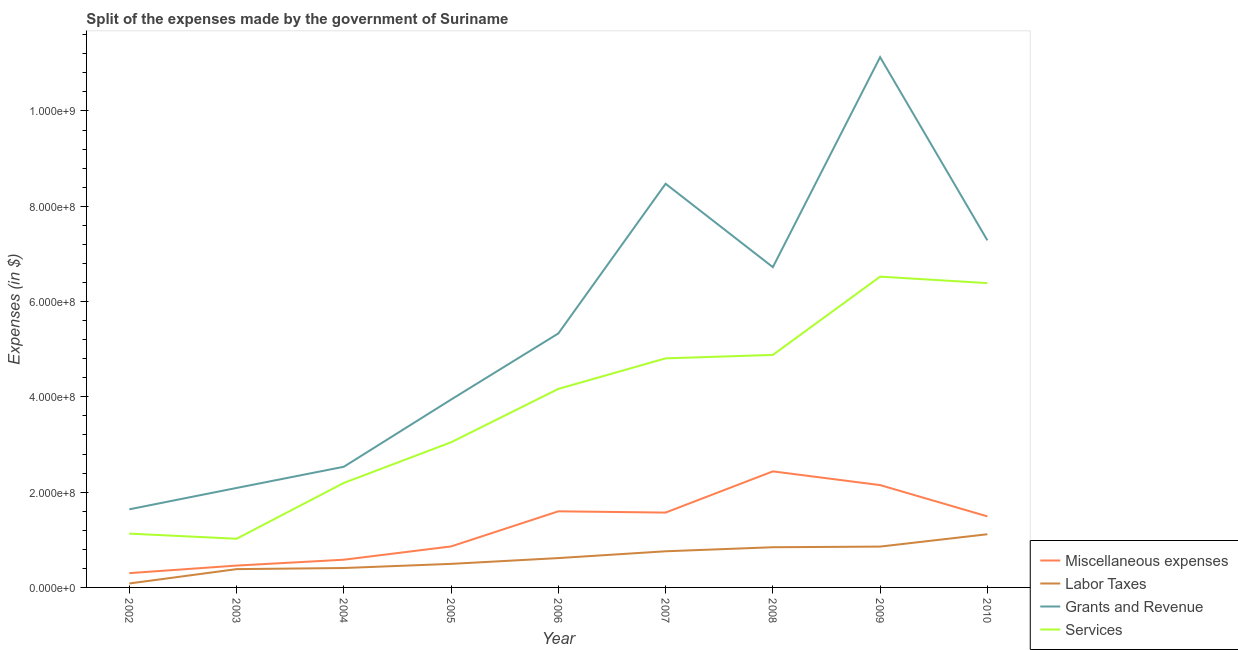How many different coloured lines are there?
Your response must be concise. 4. Is the number of lines equal to the number of legend labels?
Offer a terse response. Yes. What is the amount spent on services in 2008?
Offer a terse response. 4.88e+08. Across all years, what is the maximum amount spent on grants and revenue?
Your answer should be very brief. 1.11e+09. Across all years, what is the minimum amount spent on labor taxes?
Make the answer very short. 8.28e+06. What is the total amount spent on miscellaneous expenses in the graph?
Keep it short and to the point. 1.14e+09. What is the difference between the amount spent on grants and revenue in 2006 and that in 2007?
Make the answer very short. -3.14e+08. What is the difference between the amount spent on services in 2004 and the amount spent on miscellaneous expenses in 2008?
Your response must be concise. -2.42e+07. What is the average amount spent on grants and revenue per year?
Provide a short and direct response. 5.46e+08. In the year 2006, what is the difference between the amount spent on services and amount spent on miscellaneous expenses?
Offer a terse response. 2.57e+08. What is the ratio of the amount spent on labor taxes in 2004 to that in 2008?
Keep it short and to the point. 0.48. Is the amount spent on grants and revenue in 2004 less than that in 2005?
Keep it short and to the point. Yes. What is the difference between the highest and the second highest amount spent on miscellaneous expenses?
Give a very brief answer. 2.88e+07. What is the difference between the highest and the lowest amount spent on miscellaneous expenses?
Your answer should be very brief. 2.14e+08. In how many years, is the amount spent on miscellaneous expenses greater than the average amount spent on miscellaneous expenses taken over all years?
Offer a terse response. 5. Is it the case that in every year, the sum of the amount spent on miscellaneous expenses and amount spent on labor taxes is greater than the amount spent on grants and revenue?
Offer a very short reply. No. Is the amount spent on grants and revenue strictly greater than the amount spent on labor taxes over the years?
Offer a very short reply. Yes. Is the amount spent on services strictly less than the amount spent on labor taxes over the years?
Your response must be concise. No. How many lines are there?
Keep it short and to the point. 4. Does the graph contain grids?
Make the answer very short. No. Where does the legend appear in the graph?
Ensure brevity in your answer.  Bottom right. How many legend labels are there?
Offer a very short reply. 4. What is the title of the graph?
Your response must be concise. Split of the expenses made by the government of Suriname. Does "Tertiary schools" appear as one of the legend labels in the graph?
Your answer should be compact. No. What is the label or title of the X-axis?
Provide a succinct answer. Year. What is the label or title of the Y-axis?
Provide a succinct answer. Expenses (in $). What is the Expenses (in $) in Miscellaneous expenses in 2002?
Provide a succinct answer. 3.00e+07. What is the Expenses (in $) in Labor Taxes in 2002?
Make the answer very short. 8.28e+06. What is the Expenses (in $) in Grants and Revenue in 2002?
Keep it short and to the point. 1.64e+08. What is the Expenses (in $) of Services in 2002?
Ensure brevity in your answer.  1.13e+08. What is the Expenses (in $) in Miscellaneous expenses in 2003?
Your response must be concise. 4.59e+07. What is the Expenses (in $) in Labor Taxes in 2003?
Your response must be concise. 3.84e+07. What is the Expenses (in $) in Grants and Revenue in 2003?
Keep it short and to the point. 2.09e+08. What is the Expenses (in $) of Services in 2003?
Provide a short and direct response. 1.02e+08. What is the Expenses (in $) of Miscellaneous expenses in 2004?
Give a very brief answer. 5.82e+07. What is the Expenses (in $) in Labor Taxes in 2004?
Offer a very short reply. 4.07e+07. What is the Expenses (in $) in Grants and Revenue in 2004?
Your response must be concise. 2.53e+08. What is the Expenses (in $) in Services in 2004?
Your answer should be compact. 2.19e+08. What is the Expenses (in $) in Miscellaneous expenses in 2005?
Offer a very short reply. 8.60e+07. What is the Expenses (in $) in Labor Taxes in 2005?
Ensure brevity in your answer.  4.94e+07. What is the Expenses (in $) of Grants and Revenue in 2005?
Your response must be concise. 3.94e+08. What is the Expenses (in $) of Services in 2005?
Ensure brevity in your answer.  3.05e+08. What is the Expenses (in $) of Miscellaneous expenses in 2006?
Offer a terse response. 1.60e+08. What is the Expenses (in $) of Labor Taxes in 2006?
Your response must be concise. 6.16e+07. What is the Expenses (in $) in Grants and Revenue in 2006?
Offer a terse response. 5.33e+08. What is the Expenses (in $) of Services in 2006?
Your answer should be very brief. 4.17e+08. What is the Expenses (in $) in Miscellaneous expenses in 2007?
Your answer should be compact. 1.57e+08. What is the Expenses (in $) in Labor Taxes in 2007?
Give a very brief answer. 7.59e+07. What is the Expenses (in $) in Grants and Revenue in 2007?
Offer a very short reply. 8.47e+08. What is the Expenses (in $) of Services in 2007?
Your answer should be compact. 4.81e+08. What is the Expenses (in $) of Miscellaneous expenses in 2008?
Offer a very short reply. 2.44e+08. What is the Expenses (in $) in Labor Taxes in 2008?
Your response must be concise. 8.44e+07. What is the Expenses (in $) of Grants and Revenue in 2008?
Provide a short and direct response. 6.72e+08. What is the Expenses (in $) of Services in 2008?
Your answer should be very brief. 4.88e+08. What is the Expenses (in $) of Miscellaneous expenses in 2009?
Offer a very short reply. 2.15e+08. What is the Expenses (in $) in Labor Taxes in 2009?
Your answer should be very brief. 8.57e+07. What is the Expenses (in $) in Grants and Revenue in 2009?
Provide a succinct answer. 1.11e+09. What is the Expenses (in $) of Services in 2009?
Provide a short and direct response. 6.52e+08. What is the Expenses (in $) of Miscellaneous expenses in 2010?
Ensure brevity in your answer.  1.49e+08. What is the Expenses (in $) of Labor Taxes in 2010?
Ensure brevity in your answer.  1.12e+08. What is the Expenses (in $) in Grants and Revenue in 2010?
Your answer should be very brief. 7.28e+08. What is the Expenses (in $) in Services in 2010?
Ensure brevity in your answer.  6.39e+08. Across all years, what is the maximum Expenses (in $) of Miscellaneous expenses?
Your response must be concise. 2.44e+08. Across all years, what is the maximum Expenses (in $) in Labor Taxes?
Make the answer very short. 1.12e+08. Across all years, what is the maximum Expenses (in $) in Grants and Revenue?
Ensure brevity in your answer.  1.11e+09. Across all years, what is the maximum Expenses (in $) of Services?
Give a very brief answer. 6.52e+08. Across all years, what is the minimum Expenses (in $) of Miscellaneous expenses?
Make the answer very short. 3.00e+07. Across all years, what is the minimum Expenses (in $) in Labor Taxes?
Give a very brief answer. 8.28e+06. Across all years, what is the minimum Expenses (in $) of Grants and Revenue?
Ensure brevity in your answer.  1.64e+08. Across all years, what is the minimum Expenses (in $) in Services?
Provide a short and direct response. 1.02e+08. What is the total Expenses (in $) in Miscellaneous expenses in the graph?
Give a very brief answer. 1.14e+09. What is the total Expenses (in $) in Labor Taxes in the graph?
Provide a succinct answer. 5.56e+08. What is the total Expenses (in $) of Grants and Revenue in the graph?
Your answer should be very brief. 4.91e+09. What is the total Expenses (in $) in Services in the graph?
Provide a succinct answer. 3.42e+09. What is the difference between the Expenses (in $) in Miscellaneous expenses in 2002 and that in 2003?
Make the answer very short. -1.59e+07. What is the difference between the Expenses (in $) of Labor Taxes in 2002 and that in 2003?
Keep it short and to the point. -3.01e+07. What is the difference between the Expenses (in $) in Grants and Revenue in 2002 and that in 2003?
Your response must be concise. -4.48e+07. What is the difference between the Expenses (in $) of Services in 2002 and that in 2003?
Provide a succinct answer. 1.08e+07. What is the difference between the Expenses (in $) in Miscellaneous expenses in 2002 and that in 2004?
Your answer should be very brief. -2.82e+07. What is the difference between the Expenses (in $) in Labor Taxes in 2002 and that in 2004?
Provide a succinct answer. -3.24e+07. What is the difference between the Expenses (in $) of Grants and Revenue in 2002 and that in 2004?
Your answer should be compact. -8.93e+07. What is the difference between the Expenses (in $) in Services in 2002 and that in 2004?
Keep it short and to the point. -1.06e+08. What is the difference between the Expenses (in $) in Miscellaneous expenses in 2002 and that in 2005?
Ensure brevity in your answer.  -5.60e+07. What is the difference between the Expenses (in $) of Labor Taxes in 2002 and that in 2005?
Ensure brevity in your answer.  -4.11e+07. What is the difference between the Expenses (in $) of Grants and Revenue in 2002 and that in 2005?
Your answer should be compact. -2.30e+08. What is the difference between the Expenses (in $) in Services in 2002 and that in 2005?
Offer a very short reply. -1.92e+08. What is the difference between the Expenses (in $) of Miscellaneous expenses in 2002 and that in 2006?
Provide a short and direct response. -1.30e+08. What is the difference between the Expenses (in $) of Labor Taxes in 2002 and that in 2006?
Your answer should be compact. -5.33e+07. What is the difference between the Expenses (in $) of Grants and Revenue in 2002 and that in 2006?
Keep it short and to the point. -3.69e+08. What is the difference between the Expenses (in $) of Services in 2002 and that in 2006?
Make the answer very short. -3.04e+08. What is the difference between the Expenses (in $) in Miscellaneous expenses in 2002 and that in 2007?
Ensure brevity in your answer.  -1.27e+08. What is the difference between the Expenses (in $) in Labor Taxes in 2002 and that in 2007?
Make the answer very short. -6.76e+07. What is the difference between the Expenses (in $) in Grants and Revenue in 2002 and that in 2007?
Keep it short and to the point. -6.83e+08. What is the difference between the Expenses (in $) in Services in 2002 and that in 2007?
Your answer should be very brief. -3.68e+08. What is the difference between the Expenses (in $) of Miscellaneous expenses in 2002 and that in 2008?
Provide a short and direct response. -2.14e+08. What is the difference between the Expenses (in $) in Labor Taxes in 2002 and that in 2008?
Your response must be concise. -7.61e+07. What is the difference between the Expenses (in $) of Grants and Revenue in 2002 and that in 2008?
Make the answer very short. -5.08e+08. What is the difference between the Expenses (in $) in Services in 2002 and that in 2008?
Make the answer very short. -3.75e+08. What is the difference between the Expenses (in $) of Miscellaneous expenses in 2002 and that in 2009?
Your answer should be very brief. -1.85e+08. What is the difference between the Expenses (in $) in Labor Taxes in 2002 and that in 2009?
Ensure brevity in your answer.  -7.74e+07. What is the difference between the Expenses (in $) in Grants and Revenue in 2002 and that in 2009?
Provide a succinct answer. -9.49e+08. What is the difference between the Expenses (in $) of Services in 2002 and that in 2009?
Give a very brief answer. -5.39e+08. What is the difference between the Expenses (in $) in Miscellaneous expenses in 2002 and that in 2010?
Ensure brevity in your answer.  -1.19e+08. What is the difference between the Expenses (in $) in Labor Taxes in 2002 and that in 2010?
Give a very brief answer. -1.03e+08. What is the difference between the Expenses (in $) of Grants and Revenue in 2002 and that in 2010?
Offer a very short reply. -5.65e+08. What is the difference between the Expenses (in $) in Services in 2002 and that in 2010?
Provide a short and direct response. -5.26e+08. What is the difference between the Expenses (in $) of Miscellaneous expenses in 2003 and that in 2004?
Provide a short and direct response. -1.23e+07. What is the difference between the Expenses (in $) in Labor Taxes in 2003 and that in 2004?
Provide a succinct answer. -2.33e+06. What is the difference between the Expenses (in $) of Grants and Revenue in 2003 and that in 2004?
Ensure brevity in your answer.  -4.45e+07. What is the difference between the Expenses (in $) in Services in 2003 and that in 2004?
Provide a short and direct response. -1.17e+08. What is the difference between the Expenses (in $) of Miscellaneous expenses in 2003 and that in 2005?
Offer a very short reply. -4.02e+07. What is the difference between the Expenses (in $) of Labor Taxes in 2003 and that in 2005?
Give a very brief answer. -1.10e+07. What is the difference between the Expenses (in $) of Grants and Revenue in 2003 and that in 2005?
Offer a very short reply. -1.86e+08. What is the difference between the Expenses (in $) of Services in 2003 and that in 2005?
Make the answer very short. -2.02e+08. What is the difference between the Expenses (in $) in Miscellaneous expenses in 2003 and that in 2006?
Provide a short and direct response. -1.14e+08. What is the difference between the Expenses (in $) in Labor Taxes in 2003 and that in 2006?
Give a very brief answer. -2.32e+07. What is the difference between the Expenses (in $) of Grants and Revenue in 2003 and that in 2006?
Offer a terse response. -3.24e+08. What is the difference between the Expenses (in $) of Services in 2003 and that in 2006?
Your answer should be very brief. -3.15e+08. What is the difference between the Expenses (in $) in Miscellaneous expenses in 2003 and that in 2007?
Ensure brevity in your answer.  -1.11e+08. What is the difference between the Expenses (in $) in Labor Taxes in 2003 and that in 2007?
Keep it short and to the point. -3.75e+07. What is the difference between the Expenses (in $) of Grants and Revenue in 2003 and that in 2007?
Provide a succinct answer. -6.38e+08. What is the difference between the Expenses (in $) in Services in 2003 and that in 2007?
Keep it short and to the point. -3.79e+08. What is the difference between the Expenses (in $) of Miscellaneous expenses in 2003 and that in 2008?
Your answer should be compact. -1.98e+08. What is the difference between the Expenses (in $) of Labor Taxes in 2003 and that in 2008?
Your answer should be very brief. -4.60e+07. What is the difference between the Expenses (in $) in Grants and Revenue in 2003 and that in 2008?
Offer a very short reply. -4.63e+08. What is the difference between the Expenses (in $) of Services in 2003 and that in 2008?
Ensure brevity in your answer.  -3.86e+08. What is the difference between the Expenses (in $) of Miscellaneous expenses in 2003 and that in 2009?
Make the answer very short. -1.69e+08. What is the difference between the Expenses (in $) of Labor Taxes in 2003 and that in 2009?
Ensure brevity in your answer.  -4.73e+07. What is the difference between the Expenses (in $) in Grants and Revenue in 2003 and that in 2009?
Your response must be concise. -9.04e+08. What is the difference between the Expenses (in $) of Services in 2003 and that in 2009?
Your answer should be very brief. -5.50e+08. What is the difference between the Expenses (in $) in Miscellaneous expenses in 2003 and that in 2010?
Keep it short and to the point. -1.03e+08. What is the difference between the Expenses (in $) in Labor Taxes in 2003 and that in 2010?
Offer a very short reply. -7.32e+07. What is the difference between the Expenses (in $) in Grants and Revenue in 2003 and that in 2010?
Give a very brief answer. -5.20e+08. What is the difference between the Expenses (in $) in Services in 2003 and that in 2010?
Give a very brief answer. -5.37e+08. What is the difference between the Expenses (in $) of Miscellaneous expenses in 2004 and that in 2005?
Your response must be concise. -2.79e+07. What is the difference between the Expenses (in $) in Labor Taxes in 2004 and that in 2005?
Give a very brief answer. -8.70e+06. What is the difference between the Expenses (in $) in Grants and Revenue in 2004 and that in 2005?
Make the answer very short. -1.41e+08. What is the difference between the Expenses (in $) in Services in 2004 and that in 2005?
Provide a short and direct response. -8.53e+07. What is the difference between the Expenses (in $) of Miscellaneous expenses in 2004 and that in 2006?
Offer a terse response. -1.02e+08. What is the difference between the Expenses (in $) in Labor Taxes in 2004 and that in 2006?
Keep it short and to the point. -2.09e+07. What is the difference between the Expenses (in $) of Grants and Revenue in 2004 and that in 2006?
Give a very brief answer. -2.80e+08. What is the difference between the Expenses (in $) of Services in 2004 and that in 2006?
Keep it short and to the point. -1.97e+08. What is the difference between the Expenses (in $) of Miscellaneous expenses in 2004 and that in 2007?
Keep it short and to the point. -9.89e+07. What is the difference between the Expenses (in $) of Labor Taxes in 2004 and that in 2007?
Keep it short and to the point. -3.51e+07. What is the difference between the Expenses (in $) of Grants and Revenue in 2004 and that in 2007?
Provide a succinct answer. -5.94e+08. What is the difference between the Expenses (in $) in Services in 2004 and that in 2007?
Provide a short and direct response. -2.61e+08. What is the difference between the Expenses (in $) in Miscellaneous expenses in 2004 and that in 2008?
Offer a very short reply. -1.85e+08. What is the difference between the Expenses (in $) in Labor Taxes in 2004 and that in 2008?
Ensure brevity in your answer.  -4.36e+07. What is the difference between the Expenses (in $) of Grants and Revenue in 2004 and that in 2008?
Offer a very short reply. -4.19e+08. What is the difference between the Expenses (in $) in Services in 2004 and that in 2008?
Offer a terse response. -2.69e+08. What is the difference between the Expenses (in $) of Miscellaneous expenses in 2004 and that in 2009?
Ensure brevity in your answer.  -1.57e+08. What is the difference between the Expenses (in $) of Labor Taxes in 2004 and that in 2009?
Make the answer very short. -4.50e+07. What is the difference between the Expenses (in $) in Grants and Revenue in 2004 and that in 2009?
Ensure brevity in your answer.  -8.60e+08. What is the difference between the Expenses (in $) of Services in 2004 and that in 2009?
Offer a terse response. -4.33e+08. What is the difference between the Expenses (in $) in Miscellaneous expenses in 2004 and that in 2010?
Make the answer very short. -9.10e+07. What is the difference between the Expenses (in $) of Labor Taxes in 2004 and that in 2010?
Your answer should be compact. -7.09e+07. What is the difference between the Expenses (in $) of Grants and Revenue in 2004 and that in 2010?
Your answer should be compact. -4.75e+08. What is the difference between the Expenses (in $) in Services in 2004 and that in 2010?
Your answer should be very brief. -4.19e+08. What is the difference between the Expenses (in $) in Miscellaneous expenses in 2005 and that in 2006?
Make the answer very short. -7.37e+07. What is the difference between the Expenses (in $) of Labor Taxes in 2005 and that in 2006?
Your response must be concise. -1.22e+07. What is the difference between the Expenses (in $) of Grants and Revenue in 2005 and that in 2006?
Your answer should be compact. -1.39e+08. What is the difference between the Expenses (in $) in Services in 2005 and that in 2006?
Ensure brevity in your answer.  -1.12e+08. What is the difference between the Expenses (in $) in Miscellaneous expenses in 2005 and that in 2007?
Ensure brevity in your answer.  -7.11e+07. What is the difference between the Expenses (in $) in Labor Taxes in 2005 and that in 2007?
Give a very brief answer. -2.64e+07. What is the difference between the Expenses (in $) of Grants and Revenue in 2005 and that in 2007?
Ensure brevity in your answer.  -4.53e+08. What is the difference between the Expenses (in $) in Services in 2005 and that in 2007?
Your answer should be very brief. -1.76e+08. What is the difference between the Expenses (in $) of Miscellaneous expenses in 2005 and that in 2008?
Your answer should be compact. -1.58e+08. What is the difference between the Expenses (in $) of Labor Taxes in 2005 and that in 2008?
Offer a terse response. -3.49e+07. What is the difference between the Expenses (in $) in Grants and Revenue in 2005 and that in 2008?
Give a very brief answer. -2.78e+08. What is the difference between the Expenses (in $) in Services in 2005 and that in 2008?
Your response must be concise. -1.83e+08. What is the difference between the Expenses (in $) in Miscellaneous expenses in 2005 and that in 2009?
Your response must be concise. -1.29e+08. What is the difference between the Expenses (in $) in Labor Taxes in 2005 and that in 2009?
Ensure brevity in your answer.  -3.63e+07. What is the difference between the Expenses (in $) in Grants and Revenue in 2005 and that in 2009?
Your response must be concise. -7.19e+08. What is the difference between the Expenses (in $) of Services in 2005 and that in 2009?
Provide a succinct answer. -3.48e+08. What is the difference between the Expenses (in $) in Miscellaneous expenses in 2005 and that in 2010?
Your answer should be very brief. -6.31e+07. What is the difference between the Expenses (in $) in Labor Taxes in 2005 and that in 2010?
Offer a terse response. -6.22e+07. What is the difference between the Expenses (in $) in Grants and Revenue in 2005 and that in 2010?
Offer a very short reply. -3.34e+08. What is the difference between the Expenses (in $) of Services in 2005 and that in 2010?
Make the answer very short. -3.34e+08. What is the difference between the Expenses (in $) of Miscellaneous expenses in 2006 and that in 2007?
Provide a succinct answer. 2.63e+06. What is the difference between the Expenses (in $) in Labor Taxes in 2006 and that in 2007?
Offer a terse response. -1.43e+07. What is the difference between the Expenses (in $) of Grants and Revenue in 2006 and that in 2007?
Your response must be concise. -3.14e+08. What is the difference between the Expenses (in $) in Services in 2006 and that in 2007?
Your answer should be compact. -6.41e+07. What is the difference between the Expenses (in $) of Miscellaneous expenses in 2006 and that in 2008?
Provide a succinct answer. -8.39e+07. What is the difference between the Expenses (in $) in Labor Taxes in 2006 and that in 2008?
Provide a succinct answer. -2.28e+07. What is the difference between the Expenses (in $) of Grants and Revenue in 2006 and that in 2008?
Your answer should be compact. -1.39e+08. What is the difference between the Expenses (in $) in Services in 2006 and that in 2008?
Provide a succinct answer. -7.13e+07. What is the difference between the Expenses (in $) of Miscellaneous expenses in 2006 and that in 2009?
Keep it short and to the point. -5.50e+07. What is the difference between the Expenses (in $) in Labor Taxes in 2006 and that in 2009?
Your answer should be very brief. -2.41e+07. What is the difference between the Expenses (in $) of Grants and Revenue in 2006 and that in 2009?
Ensure brevity in your answer.  -5.80e+08. What is the difference between the Expenses (in $) in Services in 2006 and that in 2009?
Provide a succinct answer. -2.36e+08. What is the difference between the Expenses (in $) in Miscellaneous expenses in 2006 and that in 2010?
Your answer should be very brief. 1.06e+07. What is the difference between the Expenses (in $) of Labor Taxes in 2006 and that in 2010?
Your answer should be compact. -5.00e+07. What is the difference between the Expenses (in $) in Grants and Revenue in 2006 and that in 2010?
Provide a short and direct response. -1.95e+08. What is the difference between the Expenses (in $) of Services in 2006 and that in 2010?
Your answer should be very brief. -2.22e+08. What is the difference between the Expenses (in $) of Miscellaneous expenses in 2007 and that in 2008?
Your response must be concise. -8.65e+07. What is the difference between the Expenses (in $) in Labor Taxes in 2007 and that in 2008?
Provide a short and direct response. -8.51e+06. What is the difference between the Expenses (in $) of Grants and Revenue in 2007 and that in 2008?
Keep it short and to the point. 1.75e+08. What is the difference between the Expenses (in $) in Services in 2007 and that in 2008?
Keep it short and to the point. -7.24e+06. What is the difference between the Expenses (in $) in Miscellaneous expenses in 2007 and that in 2009?
Keep it short and to the point. -5.77e+07. What is the difference between the Expenses (in $) of Labor Taxes in 2007 and that in 2009?
Provide a succinct answer. -9.85e+06. What is the difference between the Expenses (in $) in Grants and Revenue in 2007 and that in 2009?
Offer a terse response. -2.66e+08. What is the difference between the Expenses (in $) in Services in 2007 and that in 2009?
Make the answer very short. -1.71e+08. What is the difference between the Expenses (in $) in Miscellaneous expenses in 2007 and that in 2010?
Keep it short and to the point. 7.95e+06. What is the difference between the Expenses (in $) in Labor Taxes in 2007 and that in 2010?
Ensure brevity in your answer.  -3.58e+07. What is the difference between the Expenses (in $) in Grants and Revenue in 2007 and that in 2010?
Provide a succinct answer. 1.19e+08. What is the difference between the Expenses (in $) of Services in 2007 and that in 2010?
Ensure brevity in your answer.  -1.58e+08. What is the difference between the Expenses (in $) of Miscellaneous expenses in 2008 and that in 2009?
Provide a succinct answer. 2.88e+07. What is the difference between the Expenses (in $) in Labor Taxes in 2008 and that in 2009?
Ensure brevity in your answer.  -1.34e+06. What is the difference between the Expenses (in $) of Grants and Revenue in 2008 and that in 2009?
Your response must be concise. -4.41e+08. What is the difference between the Expenses (in $) of Services in 2008 and that in 2009?
Your response must be concise. -1.64e+08. What is the difference between the Expenses (in $) of Miscellaneous expenses in 2008 and that in 2010?
Offer a terse response. 9.44e+07. What is the difference between the Expenses (in $) in Labor Taxes in 2008 and that in 2010?
Offer a terse response. -2.73e+07. What is the difference between the Expenses (in $) of Grants and Revenue in 2008 and that in 2010?
Your response must be concise. -5.62e+07. What is the difference between the Expenses (in $) of Services in 2008 and that in 2010?
Ensure brevity in your answer.  -1.51e+08. What is the difference between the Expenses (in $) in Miscellaneous expenses in 2009 and that in 2010?
Offer a very short reply. 6.56e+07. What is the difference between the Expenses (in $) in Labor Taxes in 2009 and that in 2010?
Your answer should be compact. -2.59e+07. What is the difference between the Expenses (in $) in Grants and Revenue in 2009 and that in 2010?
Ensure brevity in your answer.  3.84e+08. What is the difference between the Expenses (in $) of Services in 2009 and that in 2010?
Your answer should be very brief. 1.36e+07. What is the difference between the Expenses (in $) of Miscellaneous expenses in 2002 and the Expenses (in $) of Labor Taxes in 2003?
Ensure brevity in your answer.  -8.40e+06. What is the difference between the Expenses (in $) in Miscellaneous expenses in 2002 and the Expenses (in $) in Grants and Revenue in 2003?
Give a very brief answer. -1.79e+08. What is the difference between the Expenses (in $) of Miscellaneous expenses in 2002 and the Expenses (in $) of Services in 2003?
Your answer should be very brief. -7.22e+07. What is the difference between the Expenses (in $) in Labor Taxes in 2002 and the Expenses (in $) in Grants and Revenue in 2003?
Offer a very short reply. -2.00e+08. What is the difference between the Expenses (in $) in Labor Taxes in 2002 and the Expenses (in $) in Services in 2003?
Keep it short and to the point. -9.39e+07. What is the difference between the Expenses (in $) of Grants and Revenue in 2002 and the Expenses (in $) of Services in 2003?
Give a very brief answer. 6.18e+07. What is the difference between the Expenses (in $) of Miscellaneous expenses in 2002 and the Expenses (in $) of Labor Taxes in 2004?
Your answer should be very brief. -1.07e+07. What is the difference between the Expenses (in $) in Miscellaneous expenses in 2002 and the Expenses (in $) in Grants and Revenue in 2004?
Offer a terse response. -2.23e+08. What is the difference between the Expenses (in $) in Miscellaneous expenses in 2002 and the Expenses (in $) in Services in 2004?
Your response must be concise. -1.89e+08. What is the difference between the Expenses (in $) in Labor Taxes in 2002 and the Expenses (in $) in Grants and Revenue in 2004?
Give a very brief answer. -2.45e+08. What is the difference between the Expenses (in $) in Labor Taxes in 2002 and the Expenses (in $) in Services in 2004?
Make the answer very short. -2.11e+08. What is the difference between the Expenses (in $) of Grants and Revenue in 2002 and the Expenses (in $) of Services in 2004?
Provide a succinct answer. -5.54e+07. What is the difference between the Expenses (in $) of Miscellaneous expenses in 2002 and the Expenses (in $) of Labor Taxes in 2005?
Provide a short and direct response. -1.94e+07. What is the difference between the Expenses (in $) in Miscellaneous expenses in 2002 and the Expenses (in $) in Grants and Revenue in 2005?
Your answer should be very brief. -3.64e+08. What is the difference between the Expenses (in $) of Miscellaneous expenses in 2002 and the Expenses (in $) of Services in 2005?
Make the answer very short. -2.75e+08. What is the difference between the Expenses (in $) of Labor Taxes in 2002 and the Expenses (in $) of Grants and Revenue in 2005?
Make the answer very short. -3.86e+08. What is the difference between the Expenses (in $) of Labor Taxes in 2002 and the Expenses (in $) of Services in 2005?
Provide a succinct answer. -2.96e+08. What is the difference between the Expenses (in $) of Grants and Revenue in 2002 and the Expenses (in $) of Services in 2005?
Ensure brevity in your answer.  -1.41e+08. What is the difference between the Expenses (in $) of Miscellaneous expenses in 2002 and the Expenses (in $) of Labor Taxes in 2006?
Your answer should be very brief. -3.16e+07. What is the difference between the Expenses (in $) in Miscellaneous expenses in 2002 and the Expenses (in $) in Grants and Revenue in 2006?
Your answer should be very brief. -5.03e+08. What is the difference between the Expenses (in $) in Miscellaneous expenses in 2002 and the Expenses (in $) in Services in 2006?
Give a very brief answer. -3.87e+08. What is the difference between the Expenses (in $) of Labor Taxes in 2002 and the Expenses (in $) of Grants and Revenue in 2006?
Offer a terse response. -5.25e+08. What is the difference between the Expenses (in $) in Labor Taxes in 2002 and the Expenses (in $) in Services in 2006?
Make the answer very short. -4.08e+08. What is the difference between the Expenses (in $) in Grants and Revenue in 2002 and the Expenses (in $) in Services in 2006?
Keep it short and to the point. -2.53e+08. What is the difference between the Expenses (in $) in Miscellaneous expenses in 2002 and the Expenses (in $) in Labor Taxes in 2007?
Offer a very short reply. -4.59e+07. What is the difference between the Expenses (in $) in Miscellaneous expenses in 2002 and the Expenses (in $) in Grants and Revenue in 2007?
Keep it short and to the point. -8.17e+08. What is the difference between the Expenses (in $) in Miscellaneous expenses in 2002 and the Expenses (in $) in Services in 2007?
Offer a very short reply. -4.51e+08. What is the difference between the Expenses (in $) in Labor Taxes in 2002 and the Expenses (in $) in Grants and Revenue in 2007?
Your answer should be very brief. -8.39e+08. What is the difference between the Expenses (in $) of Labor Taxes in 2002 and the Expenses (in $) of Services in 2007?
Ensure brevity in your answer.  -4.72e+08. What is the difference between the Expenses (in $) in Grants and Revenue in 2002 and the Expenses (in $) in Services in 2007?
Offer a terse response. -3.17e+08. What is the difference between the Expenses (in $) in Miscellaneous expenses in 2002 and the Expenses (in $) in Labor Taxes in 2008?
Your answer should be compact. -5.44e+07. What is the difference between the Expenses (in $) in Miscellaneous expenses in 2002 and the Expenses (in $) in Grants and Revenue in 2008?
Offer a terse response. -6.42e+08. What is the difference between the Expenses (in $) in Miscellaneous expenses in 2002 and the Expenses (in $) in Services in 2008?
Provide a succinct answer. -4.58e+08. What is the difference between the Expenses (in $) in Labor Taxes in 2002 and the Expenses (in $) in Grants and Revenue in 2008?
Your answer should be very brief. -6.64e+08. What is the difference between the Expenses (in $) in Labor Taxes in 2002 and the Expenses (in $) in Services in 2008?
Provide a succinct answer. -4.80e+08. What is the difference between the Expenses (in $) of Grants and Revenue in 2002 and the Expenses (in $) of Services in 2008?
Keep it short and to the point. -3.24e+08. What is the difference between the Expenses (in $) of Miscellaneous expenses in 2002 and the Expenses (in $) of Labor Taxes in 2009?
Make the answer very short. -5.57e+07. What is the difference between the Expenses (in $) of Miscellaneous expenses in 2002 and the Expenses (in $) of Grants and Revenue in 2009?
Your answer should be very brief. -1.08e+09. What is the difference between the Expenses (in $) of Miscellaneous expenses in 2002 and the Expenses (in $) of Services in 2009?
Give a very brief answer. -6.22e+08. What is the difference between the Expenses (in $) in Labor Taxes in 2002 and the Expenses (in $) in Grants and Revenue in 2009?
Keep it short and to the point. -1.10e+09. What is the difference between the Expenses (in $) in Labor Taxes in 2002 and the Expenses (in $) in Services in 2009?
Your response must be concise. -6.44e+08. What is the difference between the Expenses (in $) of Grants and Revenue in 2002 and the Expenses (in $) of Services in 2009?
Offer a very short reply. -4.88e+08. What is the difference between the Expenses (in $) in Miscellaneous expenses in 2002 and the Expenses (in $) in Labor Taxes in 2010?
Your answer should be compact. -8.16e+07. What is the difference between the Expenses (in $) of Miscellaneous expenses in 2002 and the Expenses (in $) of Grants and Revenue in 2010?
Give a very brief answer. -6.98e+08. What is the difference between the Expenses (in $) in Miscellaneous expenses in 2002 and the Expenses (in $) in Services in 2010?
Your answer should be compact. -6.09e+08. What is the difference between the Expenses (in $) in Labor Taxes in 2002 and the Expenses (in $) in Grants and Revenue in 2010?
Give a very brief answer. -7.20e+08. What is the difference between the Expenses (in $) in Labor Taxes in 2002 and the Expenses (in $) in Services in 2010?
Make the answer very short. -6.30e+08. What is the difference between the Expenses (in $) of Grants and Revenue in 2002 and the Expenses (in $) of Services in 2010?
Provide a short and direct response. -4.75e+08. What is the difference between the Expenses (in $) in Miscellaneous expenses in 2003 and the Expenses (in $) in Labor Taxes in 2004?
Offer a terse response. 5.13e+06. What is the difference between the Expenses (in $) of Miscellaneous expenses in 2003 and the Expenses (in $) of Grants and Revenue in 2004?
Make the answer very short. -2.07e+08. What is the difference between the Expenses (in $) of Miscellaneous expenses in 2003 and the Expenses (in $) of Services in 2004?
Provide a short and direct response. -1.73e+08. What is the difference between the Expenses (in $) of Labor Taxes in 2003 and the Expenses (in $) of Grants and Revenue in 2004?
Your answer should be compact. -2.15e+08. What is the difference between the Expenses (in $) of Labor Taxes in 2003 and the Expenses (in $) of Services in 2004?
Provide a succinct answer. -1.81e+08. What is the difference between the Expenses (in $) in Grants and Revenue in 2003 and the Expenses (in $) in Services in 2004?
Ensure brevity in your answer.  -1.06e+07. What is the difference between the Expenses (in $) of Miscellaneous expenses in 2003 and the Expenses (in $) of Labor Taxes in 2005?
Make the answer very short. -3.57e+06. What is the difference between the Expenses (in $) of Miscellaneous expenses in 2003 and the Expenses (in $) of Grants and Revenue in 2005?
Keep it short and to the point. -3.48e+08. What is the difference between the Expenses (in $) in Miscellaneous expenses in 2003 and the Expenses (in $) in Services in 2005?
Provide a succinct answer. -2.59e+08. What is the difference between the Expenses (in $) of Labor Taxes in 2003 and the Expenses (in $) of Grants and Revenue in 2005?
Your answer should be compact. -3.56e+08. What is the difference between the Expenses (in $) in Labor Taxes in 2003 and the Expenses (in $) in Services in 2005?
Make the answer very short. -2.66e+08. What is the difference between the Expenses (in $) in Grants and Revenue in 2003 and the Expenses (in $) in Services in 2005?
Ensure brevity in your answer.  -9.59e+07. What is the difference between the Expenses (in $) in Miscellaneous expenses in 2003 and the Expenses (in $) in Labor Taxes in 2006?
Provide a succinct answer. -1.57e+07. What is the difference between the Expenses (in $) in Miscellaneous expenses in 2003 and the Expenses (in $) in Grants and Revenue in 2006?
Offer a very short reply. -4.87e+08. What is the difference between the Expenses (in $) in Miscellaneous expenses in 2003 and the Expenses (in $) in Services in 2006?
Offer a terse response. -3.71e+08. What is the difference between the Expenses (in $) of Labor Taxes in 2003 and the Expenses (in $) of Grants and Revenue in 2006?
Keep it short and to the point. -4.95e+08. What is the difference between the Expenses (in $) of Labor Taxes in 2003 and the Expenses (in $) of Services in 2006?
Your answer should be compact. -3.78e+08. What is the difference between the Expenses (in $) in Grants and Revenue in 2003 and the Expenses (in $) in Services in 2006?
Ensure brevity in your answer.  -2.08e+08. What is the difference between the Expenses (in $) in Miscellaneous expenses in 2003 and the Expenses (in $) in Labor Taxes in 2007?
Provide a succinct answer. -3.00e+07. What is the difference between the Expenses (in $) in Miscellaneous expenses in 2003 and the Expenses (in $) in Grants and Revenue in 2007?
Offer a very short reply. -8.01e+08. What is the difference between the Expenses (in $) in Miscellaneous expenses in 2003 and the Expenses (in $) in Services in 2007?
Make the answer very short. -4.35e+08. What is the difference between the Expenses (in $) in Labor Taxes in 2003 and the Expenses (in $) in Grants and Revenue in 2007?
Offer a terse response. -8.09e+08. What is the difference between the Expenses (in $) in Labor Taxes in 2003 and the Expenses (in $) in Services in 2007?
Offer a terse response. -4.42e+08. What is the difference between the Expenses (in $) in Grants and Revenue in 2003 and the Expenses (in $) in Services in 2007?
Provide a short and direct response. -2.72e+08. What is the difference between the Expenses (in $) of Miscellaneous expenses in 2003 and the Expenses (in $) of Labor Taxes in 2008?
Ensure brevity in your answer.  -3.85e+07. What is the difference between the Expenses (in $) of Miscellaneous expenses in 2003 and the Expenses (in $) of Grants and Revenue in 2008?
Offer a terse response. -6.26e+08. What is the difference between the Expenses (in $) of Miscellaneous expenses in 2003 and the Expenses (in $) of Services in 2008?
Provide a succinct answer. -4.42e+08. What is the difference between the Expenses (in $) in Labor Taxes in 2003 and the Expenses (in $) in Grants and Revenue in 2008?
Provide a short and direct response. -6.34e+08. What is the difference between the Expenses (in $) in Labor Taxes in 2003 and the Expenses (in $) in Services in 2008?
Your answer should be compact. -4.50e+08. What is the difference between the Expenses (in $) in Grants and Revenue in 2003 and the Expenses (in $) in Services in 2008?
Provide a succinct answer. -2.79e+08. What is the difference between the Expenses (in $) of Miscellaneous expenses in 2003 and the Expenses (in $) of Labor Taxes in 2009?
Your answer should be very brief. -3.98e+07. What is the difference between the Expenses (in $) of Miscellaneous expenses in 2003 and the Expenses (in $) of Grants and Revenue in 2009?
Your answer should be compact. -1.07e+09. What is the difference between the Expenses (in $) in Miscellaneous expenses in 2003 and the Expenses (in $) in Services in 2009?
Your answer should be compact. -6.06e+08. What is the difference between the Expenses (in $) of Labor Taxes in 2003 and the Expenses (in $) of Grants and Revenue in 2009?
Give a very brief answer. -1.07e+09. What is the difference between the Expenses (in $) in Labor Taxes in 2003 and the Expenses (in $) in Services in 2009?
Provide a succinct answer. -6.14e+08. What is the difference between the Expenses (in $) in Grants and Revenue in 2003 and the Expenses (in $) in Services in 2009?
Provide a short and direct response. -4.43e+08. What is the difference between the Expenses (in $) in Miscellaneous expenses in 2003 and the Expenses (in $) in Labor Taxes in 2010?
Your response must be concise. -6.58e+07. What is the difference between the Expenses (in $) in Miscellaneous expenses in 2003 and the Expenses (in $) in Grants and Revenue in 2010?
Give a very brief answer. -6.83e+08. What is the difference between the Expenses (in $) of Miscellaneous expenses in 2003 and the Expenses (in $) of Services in 2010?
Make the answer very short. -5.93e+08. What is the difference between the Expenses (in $) in Labor Taxes in 2003 and the Expenses (in $) in Grants and Revenue in 2010?
Provide a succinct answer. -6.90e+08. What is the difference between the Expenses (in $) in Labor Taxes in 2003 and the Expenses (in $) in Services in 2010?
Offer a terse response. -6.00e+08. What is the difference between the Expenses (in $) in Grants and Revenue in 2003 and the Expenses (in $) in Services in 2010?
Make the answer very short. -4.30e+08. What is the difference between the Expenses (in $) in Miscellaneous expenses in 2004 and the Expenses (in $) in Labor Taxes in 2005?
Ensure brevity in your answer.  8.74e+06. What is the difference between the Expenses (in $) in Miscellaneous expenses in 2004 and the Expenses (in $) in Grants and Revenue in 2005?
Ensure brevity in your answer.  -3.36e+08. What is the difference between the Expenses (in $) of Miscellaneous expenses in 2004 and the Expenses (in $) of Services in 2005?
Your answer should be very brief. -2.46e+08. What is the difference between the Expenses (in $) in Labor Taxes in 2004 and the Expenses (in $) in Grants and Revenue in 2005?
Offer a terse response. -3.54e+08. What is the difference between the Expenses (in $) in Labor Taxes in 2004 and the Expenses (in $) in Services in 2005?
Offer a terse response. -2.64e+08. What is the difference between the Expenses (in $) of Grants and Revenue in 2004 and the Expenses (in $) of Services in 2005?
Offer a terse response. -5.14e+07. What is the difference between the Expenses (in $) in Miscellaneous expenses in 2004 and the Expenses (in $) in Labor Taxes in 2006?
Make the answer very short. -3.42e+06. What is the difference between the Expenses (in $) in Miscellaneous expenses in 2004 and the Expenses (in $) in Grants and Revenue in 2006?
Provide a succinct answer. -4.75e+08. What is the difference between the Expenses (in $) of Miscellaneous expenses in 2004 and the Expenses (in $) of Services in 2006?
Offer a terse response. -3.58e+08. What is the difference between the Expenses (in $) in Labor Taxes in 2004 and the Expenses (in $) in Grants and Revenue in 2006?
Your response must be concise. -4.92e+08. What is the difference between the Expenses (in $) of Labor Taxes in 2004 and the Expenses (in $) of Services in 2006?
Your answer should be very brief. -3.76e+08. What is the difference between the Expenses (in $) in Grants and Revenue in 2004 and the Expenses (in $) in Services in 2006?
Offer a terse response. -1.63e+08. What is the difference between the Expenses (in $) in Miscellaneous expenses in 2004 and the Expenses (in $) in Labor Taxes in 2007?
Provide a succinct answer. -1.77e+07. What is the difference between the Expenses (in $) in Miscellaneous expenses in 2004 and the Expenses (in $) in Grants and Revenue in 2007?
Your answer should be compact. -7.89e+08. What is the difference between the Expenses (in $) of Miscellaneous expenses in 2004 and the Expenses (in $) of Services in 2007?
Provide a short and direct response. -4.23e+08. What is the difference between the Expenses (in $) of Labor Taxes in 2004 and the Expenses (in $) of Grants and Revenue in 2007?
Give a very brief answer. -8.06e+08. What is the difference between the Expenses (in $) of Labor Taxes in 2004 and the Expenses (in $) of Services in 2007?
Keep it short and to the point. -4.40e+08. What is the difference between the Expenses (in $) of Grants and Revenue in 2004 and the Expenses (in $) of Services in 2007?
Ensure brevity in your answer.  -2.28e+08. What is the difference between the Expenses (in $) in Miscellaneous expenses in 2004 and the Expenses (in $) in Labor Taxes in 2008?
Give a very brief answer. -2.62e+07. What is the difference between the Expenses (in $) in Miscellaneous expenses in 2004 and the Expenses (in $) in Grants and Revenue in 2008?
Provide a short and direct response. -6.14e+08. What is the difference between the Expenses (in $) of Miscellaneous expenses in 2004 and the Expenses (in $) of Services in 2008?
Your response must be concise. -4.30e+08. What is the difference between the Expenses (in $) in Labor Taxes in 2004 and the Expenses (in $) in Grants and Revenue in 2008?
Keep it short and to the point. -6.31e+08. What is the difference between the Expenses (in $) of Labor Taxes in 2004 and the Expenses (in $) of Services in 2008?
Your response must be concise. -4.47e+08. What is the difference between the Expenses (in $) in Grants and Revenue in 2004 and the Expenses (in $) in Services in 2008?
Keep it short and to the point. -2.35e+08. What is the difference between the Expenses (in $) of Miscellaneous expenses in 2004 and the Expenses (in $) of Labor Taxes in 2009?
Your response must be concise. -2.75e+07. What is the difference between the Expenses (in $) of Miscellaneous expenses in 2004 and the Expenses (in $) of Grants and Revenue in 2009?
Provide a succinct answer. -1.05e+09. What is the difference between the Expenses (in $) of Miscellaneous expenses in 2004 and the Expenses (in $) of Services in 2009?
Keep it short and to the point. -5.94e+08. What is the difference between the Expenses (in $) in Labor Taxes in 2004 and the Expenses (in $) in Grants and Revenue in 2009?
Your answer should be very brief. -1.07e+09. What is the difference between the Expenses (in $) in Labor Taxes in 2004 and the Expenses (in $) in Services in 2009?
Make the answer very short. -6.12e+08. What is the difference between the Expenses (in $) in Grants and Revenue in 2004 and the Expenses (in $) in Services in 2009?
Ensure brevity in your answer.  -3.99e+08. What is the difference between the Expenses (in $) of Miscellaneous expenses in 2004 and the Expenses (in $) of Labor Taxes in 2010?
Your answer should be very brief. -5.35e+07. What is the difference between the Expenses (in $) of Miscellaneous expenses in 2004 and the Expenses (in $) of Grants and Revenue in 2010?
Your answer should be very brief. -6.70e+08. What is the difference between the Expenses (in $) in Miscellaneous expenses in 2004 and the Expenses (in $) in Services in 2010?
Your response must be concise. -5.81e+08. What is the difference between the Expenses (in $) in Labor Taxes in 2004 and the Expenses (in $) in Grants and Revenue in 2010?
Offer a terse response. -6.88e+08. What is the difference between the Expenses (in $) in Labor Taxes in 2004 and the Expenses (in $) in Services in 2010?
Provide a short and direct response. -5.98e+08. What is the difference between the Expenses (in $) of Grants and Revenue in 2004 and the Expenses (in $) of Services in 2010?
Make the answer very short. -3.85e+08. What is the difference between the Expenses (in $) of Miscellaneous expenses in 2005 and the Expenses (in $) of Labor Taxes in 2006?
Offer a terse response. 2.45e+07. What is the difference between the Expenses (in $) of Miscellaneous expenses in 2005 and the Expenses (in $) of Grants and Revenue in 2006?
Your answer should be very brief. -4.47e+08. What is the difference between the Expenses (in $) in Miscellaneous expenses in 2005 and the Expenses (in $) in Services in 2006?
Offer a terse response. -3.31e+08. What is the difference between the Expenses (in $) in Labor Taxes in 2005 and the Expenses (in $) in Grants and Revenue in 2006?
Make the answer very short. -4.84e+08. What is the difference between the Expenses (in $) in Labor Taxes in 2005 and the Expenses (in $) in Services in 2006?
Your answer should be compact. -3.67e+08. What is the difference between the Expenses (in $) of Grants and Revenue in 2005 and the Expenses (in $) of Services in 2006?
Your response must be concise. -2.24e+07. What is the difference between the Expenses (in $) of Miscellaneous expenses in 2005 and the Expenses (in $) of Labor Taxes in 2007?
Offer a terse response. 1.02e+07. What is the difference between the Expenses (in $) of Miscellaneous expenses in 2005 and the Expenses (in $) of Grants and Revenue in 2007?
Provide a succinct answer. -7.61e+08. What is the difference between the Expenses (in $) of Miscellaneous expenses in 2005 and the Expenses (in $) of Services in 2007?
Keep it short and to the point. -3.95e+08. What is the difference between the Expenses (in $) of Labor Taxes in 2005 and the Expenses (in $) of Grants and Revenue in 2007?
Offer a very short reply. -7.98e+08. What is the difference between the Expenses (in $) of Labor Taxes in 2005 and the Expenses (in $) of Services in 2007?
Keep it short and to the point. -4.31e+08. What is the difference between the Expenses (in $) in Grants and Revenue in 2005 and the Expenses (in $) in Services in 2007?
Your answer should be very brief. -8.65e+07. What is the difference between the Expenses (in $) of Miscellaneous expenses in 2005 and the Expenses (in $) of Labor Taxes in 2008?
Provide a succinct answer. 1.68e+06. What is the difference between the Expenses (in $) in Miscellaneous expenses in 2005 and the Expenses (in $) in Grants and Revenue in 2008?
Give a very brief answer. -5.86e+08. What is the difference between the Expenses (in $) in Miscellaneous expenses in 2005 and the Expenses (in $) in Services in 2008?
Provide a succinct answer. -4.02e+08. What is the difference between the Expenses (in $) in Labor Taxes in 2005 and the Expenses (in $) in Grants and Revenue in 2008?
Make the answer very short. -6.23e+08. What is the difference between the Expenses (in $) in Labor Taxes in 2005 and the Expenses (in $) in Services in 2008?
Ensure brevity in your answer.  -4.39e+08. What is the difference between the Expenses (in $) in Grants and Revenue in 2005 and the Expenses (in $) in Services in 2008?
Keep it short and to the point. -9.37e+07. What is the difference between the Expenses (in $) in Miscellaneous expenses in 2005 and the Expenses (in $) in Labor Taxes in 2009?
Keep it short and to the point. 3.38e+05. What is the difference between the Expenses (in $) in Miscellaneous expenses in 2005 and the Expenses (in $) in Grants and Revenue in 2009?
Your answer should be very brief. -1.03e+09. What is the difference between the Expenses (in $) in Miscellaneous expenses in 2005 and the Expenses (in $) in Services in 2009?
Your answer should be compact. -5.66e+08. What is the difference between the Expenses (in $) in Labor Taxes in 2005 and the Expenses (in $) in Grants and Revenue in 2009?
Your answer should be compact. -1.06e+09. What is the difference between the Expenses (in $) in Labor Taxes in 2005 and the Expenses (in $) in Services in 2009?
Offer a very short reply. -6.03e+08. What is the difference between the Expenses (in $) in Grants and Revenue in 2005 and the Expenses (in $) in Services in 2009?
Keep it short and to the point. -2.58e+08. What is the difference between the Expenses (in $) of Miscellaneous expenses in 2005 and the Expenses (in $) of Labor Taxes in 2010?
Give a very brief answer. -2.56e+07. What is the difference between the Expenses (in $) in Miscellaneous expenses in 2005 and the Expenses (in $) in Grants and Revenue in 2010?
Your answer should be very brief. -6.42e+08. What is the difference between the Expenses (in $) of Miscellaneous expenses in 2005 and the Expenses (in $) of Services in 2010?
Your response must be concise. -5.53e+08. What is the difference between the Expenses (in $) of Labor Taxes in 2005 and the Expenses (in $) of Grants and Revenue in 2010?
Provide a short and direct response. -6.79e+08. What is the difference between the Expenses (in $) in Labor Taxes in 2005 and the Expenses (in $) in Services in 2010?
Make the answer very short. -5.89e+08. What is the difference between the Expenses (in $) in Grants and Revenue in 2005 and the Expenses (in $) in Services in 2010?
Offer a terse response. -2.44e+08. What is the difference between the Expenses (in $) of Miscellaneous expenses in 2006 and the Expenses (in $) of Labor Taxes in 2007?
Your response must be concise. 8.39e+07. What is the difference between the Expenses (in $) in Miscellaneous expenses in 2006 and the Expenses (in $) in Grants and Revenue in 2007?
Your response must be concise. -6.87e+08. What is the difference between the Expenses (in $) in Miscellaneous expenses in 2006 and the Expenses (in $) in Services in 2007?
Your response must be concise. -3.21e+08. What is the difference between the Expenses (in $) in Labor Taxes in 2006 and the Expenses (in $) in Grants and Revenue in 2007?
Keep it short and to the point. -7.86e+08. What is the difference between the Expenses (in $) of Labor Taxes in 2006 and the Expenses (in $) of Services in 2007?
Offer a terse response. -4.19e+08. What is the difference between the Expenses (in $) of Grants and Revenue in 2006 and the Expenses (in $) of Services in 2007?
Ensure brevity in your answer.  5.23e+07. What is the difference between the Expenses (in $) of Miscellaneous expenses in 2006 and the Expenses (in $) of Labor Taxes in 2008?
Keep it short and to the point. 7.54e+07. What is the difference between the Expenses (in $) of Miscellaneous expenses in 2006 and the Expenses (in $) of Grants and Revenue in 2008?
Your answer should be very brief. -5.12e+08. What is the difference between the Expenses (in $) of Miscellaneous expenses in 2006 and the Expenses (in $) of Services in 2008?
Provide a short and direct response. -3.28e+08. What is the difference between the Expenses (in $) in Labor Taxes in 2006 and the Expenses (in $) in Grants and Revenue in 2008?
Your answer should be very brief. -6.11e+08. What is the difference between the Expenses (in $) in Labor Taxes in 2006 and the Expenses (in $) in Services in 2008?
Your response must be concise. -4.26e+08. What is the difference between the Expenses (in $) in Grants and Revenue in 2006 and the Expenses (in $) in Services in 2008?
Ensure brevity in your answer.  4.50e+07. What is the difference between the Expenses (in $) in Miscellaneous expenses in 2006 and the Expenses (in $) in Labor Taxes in 2009?
Ensure brevity in your answer.  7.40e+07. What is the difference between the Expenses (in $) in Miscellaneous expenses in 2006 and the Expenses (in $) in Grants and Revenue in 2009?
Offer a very short reply. -9.53e+08. What is the difference between the Expenses (in $) of Miscellaneous expenses in 2006 and the Expenses (in $) of Services in 2009?
Your answer should be compact. -4.93e+08. What is the difference between the Expenses (in $) in Labor Taxes in 2006 and the Expenses (in $) in Grants and Revenue in 2009?
Your answer should be compact. -1.05e+09. What is the difference between the Expenses (in $) in Labor Taxes in 2006 and the Expenses (in $) in Services in 2009?
Provide a succinct answer. -5.91e+08. What is the difference between the Expenses (in $) in Grants and Revenue in 2006 and the Expenses (in $) in Services in 2009?
Your answer should be very brief. -1.19e+08. What is the difference between the Expenses (in $) of Miscellaneous expenses in 2006 and the Expenses (in $) of Labor Taxes in 2010?
Provide a short and direct response. 4.81e+07. What is the difference between the Expenses (in $) in Miscellaneous expenses in 2006 and the Expenses (in $) in Grants and Revenue in 2010?
Your response must be concise. -5.69e+08. What is the difference between the Expenses (in $) in Miscellaneous expenses in 2006 and the Expenses (in $) in Services in 2010?
Provide a succinct answer. -4.79e+08. What is the difference between the Expenses (in $) of Labor Taxes in 2006 and the Expenses (in $) of Grants and Revenue in 2010?
Offer a very short reply. -6.67e+08. What is the difference between the Expenses (in $) of Labor Taxes in 2006 and the Expenses (in $) of Services in 2010?
Give a very brief answer. -5.77e+08. What is the difference between the Expenses (in $) of Grants and Revenue in 2006 and the Expenses (in $) of Services in 2010?
Give a very brief answer. -1.06e+08. What is the difference between the Expenses (in $) of Miscellaneous expenses in 2007 and the Expenses (in $) of Labor Taxes in 2008?
Offer a terse response. 7.27e+07. What is the difference between the Expenses (in $) of Miscellaneous expenses in 2007 and the Expenses (in $) of Grants and Revenue in 2008?
Ensure brevity in your answer.  -5.15e+08. What is the difference between the Expenses (in $) in Miscellaneous expenses in 2007 and the Expenses (in $) in Services in 2008?
Ensure brevity in your answer.  -3.31e+08. What is the difference between the Expenses (in $) of Labor Taxes in 2007 and the Expenses (in $) of Grants and Revenue in 2008?
Offer a terse response. -5.96e+08. What is the difference between the Expenses (in $) in Labor Taxes in 2007 and the Expenses (in $) in Services in 2008?
Your answer should be compact. -4.12e+08. What is the difference between the Expenses (in $) of Grants and Revenue in 2007 and the Expenses (in $) of Services in 2008?
Provide a succinct answer. 3.59e+08. What is the difference between the Expenses (in $) in Miscellaneous expenses in 2007 and the Expenses (in $) in Labor Taxes in 2009?
Offer a very short reply. 7.14e+07. What is the difference between the Expenses (in $) of Miscellaneous expenses in 2007 and the Expenses (in $) of Grants and Revenue in 2009?
Offer a terse response. -9.56e+08. What is the difference between the Expenses (in $) in Miscellaneous expenses in 2007 and the Expenses (in $) in Services in 2009?
Give a very brief answer. -4.95e+08. What is the difference between the Expenses (in $) of Labor Taxes in 2007 and the Expenses (in $) of Grants and Revenue in 2009?
Provide a short and direct response. -1.04e+09. What is the difference between the Expenses (in $) of Labor Taxes in 2007 and the Expenses (in $) of Services in 2009?
Offer a terse response. -5.76e+08. What is the difference between the Expenses (in $) in Grants and Revenue in 2007 and the Expenses (in $) in Services in 2009?
Provide a short and direct response. 1.95e+08. What is the difference between the Expenses (in $) of Miscellaneous expenses in 2007 and the Expenses (in $) of Labor Taxes in 2010?
Your answer should be very brief. 4.55e+07. What is the difference between the Expenses (in $) in Miscellaneous expenses in 2007 and the Expenses (in $) in Grants and Revenue in 2010?
Ensure brevity in your answer.  -5.71e+08. What is the difference between the Expenses (in $) of Miscellaneous expenses in 2007 and the Expenses (in $) of Services in 2010?
Your response must be concise. -4.82e+08. What is the difference between the Expenses (in $) in Labor Taxes in 2007 and the Expenses (in $) in Grants and Revenue in 2010?
Ensure brevity in your answer.  -6.53e+08. What is the difference between the Expenses (in $) of Labor Taxes in 2007 and the Expenses (in $) of Services in 2010?
Provide a short and direct response. -5.63e+08. What is the difference between the Expenses (in $) in Grants and Revenue in 2007 and the Expenses (in $) in Services in 2010?
Make the answer very short. 2.08e+08. What is the difference between the Expenses (in $) in Miscellaneous expenses in 2008 and the Expenses (in $) in Labor Taxes in 2009?
Your answer should be compact. 1.58e+08. What is the difference between the Expenses (in $) of Miscellaneous expenses in 2008 and the Expenses (in $) of Grants and Revenue in 2009?
Ensure brevity in your answer.  -8.69e+08. What is the difference between the Expenses (in $) of Miscellaneous expenses in 2008 and the Expenses (in $) of Services in 2009?
Provide a succinct answer. -4.09e+08. What is the difference between the Expenses (in $) of Labor Taxes in 2008 and the Expenses (in $) of Grants and Revenue in 2009?
Your answer should be very brief. -1.03e+09. What is the difference between the Expenses (in $) of Labor Taxes in 2008 and the Expenses (in $) of Services in 2009?
Give a very brief answer. -5.68e+08. What is the difference between the Expenses (in $) of Grants and Revenue in 2008 and the Expenses (in $) of Services in 2009?
Your answer should be compact. 2.00e+07. What is the difference between the Expenses (in $) of Miscellaneous expenses in 2008 and the Expenses (in $) of Labor Taxes in 2010?
Provide a short and direct response. 1.32e+08. What is the difference between the Expenses (in $) of Miscellaneous expenses in 2008 and the Expenses (in $) of Grants and Revenue in 2010?
Provide a succinct answer. -4.85e+08. What is the difference between the Expenses (in $) in Miscellaneous expenses in 2008 and the Expenses (in $) in Services in 2010?
Your response must be concise. -3.95e+08. What is the difference between the Expenses (in $) in Labor Taxes in 2008 and the Expenses (in $) in Grants and Revenue in 2010?
Offer a very short reply. -6.44e+08. What is the difference between the Expenses (in $) in Labor Taxes in 2008 and the Expenses (in $) in Services in 2010?
Provide a succinct answer. -5.54e+08. What is the difference between the Expenses (in $) in Grants and Revenue in 2008 and the Expenses (in $) in Services in 2010?
Give a very brief answer. 3.35e+07. What is the difference between the Expenses (in $) in Miscellaneous expenses in 2009 and the Expenses (in $) in Labor Taxes in 2010?
Make the answer very short. 1.03e+08. What is the difference between the Expenses (in $) in Miscellaneous expenses in 2009 and the Expenses (in $) in Grants and Revenue in 2010?
Your response must be concise. -5.14e+08. What is the difference between the Expenses (in $) of Miscellaneous expenses in 2009 and the Expenses (in $) of Services in 2010?
Your answer should be compact. -4.24e+08. What is the difference between the Expenses (in $) in Labor Taxes in 2009 and the Expenses (in $) in Grants and Revenue in 2010?
Your response must be concise. -6.43e+08. What is the difference between the Expenses (in $) of Labor Taxes in 2009 and the Expenses (in $) of Services in 2010?
Keep it short and to the point. -5.53e+08. What is the difference between the Expenses (in $) of Grants and Revenue in 2009 and the Expenses (in $) of Services in 2010?
Give a very brief answer. 4.74e+08. What is the average Expenses (in $) in Miscellaneous expenses per year?
Your response must be concise. 1.27e+08. What is the average Expenses (in $) of Labor Taxes per year?
Keep it short and to the point. 6.18e+07. What is the average Expenses (in $) in Grants and Revenue per year?
Ensure brevity in your answer.  5.46e+08. What is the average Expenses (in $) of Services per year?
Provide a short and direct response. 3.79e+08. In the year 2002, what is the difference between the Expenses (in $) of Miscellaneous expenses and Expenses (in $) of Labor Taxes?
Your answer should be compact. 2.17e+07. In the year 2002, what is the difference between the Expenses (in $) of Miscellaneous expenses and Expenses (in $) of Grants and Revenue?
Offer a terse response. -1.34e+08. In the year 2002, what is the difference between the Expenses (in $) of Miscellaneous expenses and Expenses (in $) of Services?
Keep it short and to the point. -8.29e+07. In the year 2002, what is the difference between the Expenses (in $) in Labor Taxes and Expenses (in $) in Grants and Revenue?
Make the answer very short. -1.56e+08. In the year 2002, what is the difference between the Expenses (in $) in Labor Taxes and Expenses (in $) in Services?
Keep it short and to the point. -1.05e+08. In the year 2002, what is the difference between the Expenses (in $) of Grants and Revenue and Expenses (in $) of Services?
Ensure brevity in your answer.  5.10e+07. In the year 2003, what is the difference between the Expenses (in $) in Miscellaneous expenses and Expenses (in $) in Labor Taxes?
Provide a succinct answer. 7.46e+06. In the year 2003, what is the difference between the Expenses (in $) in Miscellaneous expenses and Expenses (in $) in Grants and Revenue?
Provide a short and direct response. -1.63e+08. In the year 2003, what is the difference between the Expenses (in $) of Miscellaneous expenses and Expenses (in $) of Services?
Your response must be concise. -5.63e+07. In the year 2003, what is the difference between the Expenses (in $) in Labor Taxes and Expenses (in $) in Grants and Revenue?
Your answer should be compact. -1.70e+08. In the year 2003, what is the difference between the Expenses (in $) in Labor Taxes and Expenses (in $) in Services?
Offer a terse response. -6.38e+07. In the year 2003, what is the difference between the Expenses (in $) of Grants and Revenue and Expenses (in $) of Services?
Make the answer very short. 1.07e+08. In the year 2004, what is the difference between the Expenses (in $) of Miscellaneous expenses and Expenses (in $) of Labor Taxes?
Offer a very short reply. 1.74e+07. In the year 2004, what is the difference between the Expenses (in $) of Miscellaneous expenses and Expenses (in $) of Grants and Revenue?
Your answer should be compact. -1.95e+08. In the year 2004, what is the difference between the Expenses (in $) of Miscellaneous expenses and Expenses (in $) of Services?
Your response must be concise. -1.61e+08. In the year 2004, what is the difference between the Expenses (in $) in Labor Taxes and Expenses (in $) in Grants and Revenue?
Provide a short and direct response. -2.13e+08. In the year 2004, what is the difference between the Expenses (in $) of Labor Taxes and Expenses (in $) of Services?
Your answer should be compact. -1.79e+08. In the year 2004, what is the difference between the Expenses (in $) of Grants and Revenue and Expenses (in $) of Services?
Give a very brief answer. 3.39e+07. In the year 2005, what is the difference between the Expenses (in $) in Miscellaneous expenses and Expenses (in $) in Labor Taxes?
Ensure brevity in your answer.  3.66e+07. In the year 2005, what is the difference between the Expenses (in $) in Miscellaneous expenses and Expenses (in $) in Grants and Revenue?
Your response must be concise. -3.08e+08. In the year 2005, what is the difference between the Expenses (in $) in Miscellaneous expenses and Expenses (in $) in Services?
Offer a very short reply. -2.19e+08. In the year 2005, what is the difference between the Expenses (in $) in Labor Taxes and Expenses (in $) in Grants and Revenue?
Provide a succinct answer. -3.45e+08. In the year 2005, what is the difference between the Expenses (in $) of Labor Taxes and Expenses (in $) of Services?
Make the answer very short. -2.55e+08. In the year 2005, what is the difference between the Expenses (in $) in Grants and Revenue and Expenses (in $) in Services?
Offer a terse response. 8.97e+07. In the year 2006, what is the difference between the Expenses (in $) in Miscellaneous expenses and Expenses (in $) in Labor Taxes?
Provide a short and direct response. 9.81e+07. In the year 2006, what is the difference between the Expenses (in $) in Miscellaneous expenses and Expenses (in $) in Grants and Revenue?
Make the answer very short. -3.73e+08. In the year 2006, what is the difference between the Expenses (in $) of Miscellaneous expenses and Expenses (in $) of Services?
Make the answer very short. -2.57e+08. In the year 2006, what is the difference between the Expenses (in $) of Labor Taxes and Expenses (in $) of Grants and Revenue?
Your response must be concise. -4.71e+08. In the year 2006, what is the difference between the Expenses (in $) of Labor Taxes and Expenses (in $) of Services?
Make the answer very short. -3.55e+08. In the year 2006, what is the difference between the Expenses (in $) of Grants and Revenue and Expenses (in $) of Services?
Keep it short and to the point. 1.16e+08. In the year 2007, what is the difference between the Expenses (in $) in Miscellaneous expenses and Expenses (in $) in Labor Taxes?
Offer a very short reply. 8.12e+07. In the year 2007, what is the difference between the Expenses (in $) in Miscellaneous expenses and Expenses (in $) in Grants and Revenue?
Provide a short and direct response. -6.90e+08. In the year 2007, what is the difference between the Expenses (in $) in Miscellaneous expenses and Expenses (in $) in Services?
Provide a succinct answer. -3.24e+08. In the year 2007, what is the difference between the Expenses (in $) in Labor Taxes and Expenses (in $) in Grants and Revenue?
Ensure brevity in your answer.  -7.71e+08. In the year 2007, what is the difference between the Expenses (in $) of Labor Taxes and Expenses (in $) of Services?
Keep it short and to the point. -4.05e+08. In the year 2007, what is the difference between the Expenses (in $) of Grants and Revenue and Expenses (in $) of Services?
Keep it short and to the point. 3.66e+08. In the year 2008, what is the difference between the Expenses (in $) of Miscellaneous expenses and Expenses (in $) of Labor Taxes?
Ensure brevity in your answer.  1.59e+08. In the year 2008, what is the difference between the Expenses (in $) in Miscellaneous expenses and Expenses (in $) in Grants and Revenue?
Provide a succinct answer. -4.29e+08. In the year 2008, what is the difference between the Expenses (in $) in Miscellaneous expenses and Expenses (in $) in Services?
Offer a very short reply. -2.44e+08. In the year 2008, what is the difference between the Expenses (in $) of Labor Taxes and Expenses (in $) of Grants and Revenue?
Ensure brevity in your answer.  -5.88e+08. In the year 2008, what is the difference between the Expenses (in $) of Labor Taxes and Expenses (in $) of Services?
Your response must be concise. -4.04e+08. In the year 2008, what is the difference between the Expenses (in $) in Grants and Revenue and Expenses (in $) in Services?
Provide a short and direct response. 1.84e+08. In the year 2009, what is the difference between the Expenses (in $) in Miscellaneous expenses and Expenses (in $) in Labor Taxes?
Ensure brevity in your answer.  1.29e+08. In the year 2009, what is the difference between the Expenses (in $) of Miscellaneous expenses and Expenses (in $) of Grants and Revenue?
Offer a very short reply. -8.98e+08. In the year 2009, what is the difference between the Expenses (in $) of Miscellaneous expenses and Expenses (in $) of Services?
Give a very brief answer. -4.37e+08. In the year 2009, what is the difference between the Expenses (in $) of Labor Taxes and Expenses (in $) of Grants and Revenue?
Offer a terse response. -1.03e+09. In the year 2009, what is the difference between the Expenses (in $) in Labor Taxes and Expenses (in $) in Services?
Give a very brief answer. -5.67e+08. In the year 2009, what is the difference between the Expenses (in $) of Grants and Revenue and Expenses (in $) of Services?
Keep it short and to the point. 4.61e+08. In the year 2010, what is the difference between the Expenses (in $) in Miscellaneous expenses and Expenses (in $) in Labor Taxes?
Offer a very short reply. 3.75e+07. In the year 2010, what is the difference between the Expenses (in $) of Miscellaneous expenses and Expenses (in $) of Grants and Revenue?
Make the answer very short. -5.79e+08. In the year 2010, what is the difference between the Expenses (in $) in Miscellaneous expenses and Expenses (in $) in Services?
Offer a very short reply. -4.90e+08. In the year 2010, what is the difference between the Expenses (in $) of Labor Taxes and Expenses (in $) of Grants and Revenue?
Provide a succinct answer. -6.17e+08. In the year 2010, what is the difference between the Expenses (in $) of Labor Taxes and Expenses (in $) of Services?
Your answer should be very brief. -5.27e+08. In the year 2010, what is the difference between the Expenses (in $) of Grants and Revenue and Expenses (in $) of Services?
Keep it short and to the point. 8.97e+07. What is the ratio of the Expenses (in $) of Miscellaneous expenses in 2002 to that in 2003?
Your answer should be very brief. 0.65. What is the ratio of the Expenses (in $) in Labor Taxes in 2002 to that in 2003?
Your response must be concise. 0.22. What is the ratio of the Expenses (in $) in Grants and Revenue in 2002 to that in 2003?
Offer a very short reply. 0.79. What is the ratio of the Expenses (in $) in Services in 2002 to that in 2003?
Ensure brevity in your answer.  1.11. What is the ratio of the Expenses (in $) of Miscellaneous expenses in 2002 to that in 2004?
Provide a short and direct response. 0.52. What is the ratio of the Expenses (in $) in Labor Taxes in 2002 to that in 2004?
Offer a terse response. 0.2. What is the ratio of the Expenses (in $) in Grants and Revenue in 2002 to that in 2004?
Keep it short and to the point. 0.65. What is the ratio of the Expenses (in $) of Services in 2002 to that in 2004?
Ensure brevity in your answer.  0.51. What is the ratio of the Expenses (in $) in Miscellaneous expenses in 2002 to that in 2005?
Your answer should be very brief. 0.35. What is the ratio of the Expenses (in $) in Labor Taxes in 2002 to that in 2005?
Give a very brief answer. 0.17. What is the ratio of the Expenses (in $) in Grants and Revenue in 2002 to that in 2005?
Your response must be concise. 0.42. What is the ratio of the Expenses (in $) in Services in 2002 to that in 2005?
Offer a very short reply. 0.37. What is the ratio of the Expenses (in $) of Miscellaneous expenses in 2002 to that in 2006?
Provide a short and direct response. 0.19. What is the ratio of the Expenses (in $) in Labor Taxes in 2002 to that in 2006?
Offer a terse response. 0.13. What is the ratio of the Expenses (in $) of Grants and Revenue in 2002 to that in 2006?
Give a very brief answer. 0.31. What is the ratio of the Expenses (in $) in Services in 2002 to that in 2006?
Your answer should be compact. 0.27. What is the ratio of the Expenses (in $) in Miscellaneous expenses in 2002 to that in 2007?
Give a very brief answer. 0.19. What is the ratio of the Expenses (in $) of Labor Taxes in 2002 to that in 2007?
Offer a terse response. 0.11. What is the ratio of the Expenses (in $) of Grants and Revenue in 2002 to that in 2007?
Make the answer very short. 0.19. What is the ratio of the Expenses (in $) in Services in 2002 to that in 2007?
Ensure brevity in your answer.  0.23. What is the ratio of the Expenses (in $) of Miscellaneous expenses in 2002 to that in 2008?
Give a very brief answer. 0.12. What is the ratio of the Expenses (in $) of Labor Taxes in 2002 to that in 2008?
Ensure brevity in your answer.  0.1. What is the ratio of the Expenses (in $) of Grants and Revenue in 2002 to that in 2008?
Your response must be concise. 0.24. What is the ratio of the Expenses (in $) in Services in 2002 to that in 2008?
Your response must be concise. 0.23. What is the ratio of the Expenses (in $) in Miscellaneous expenses in 2002 to that in 2009?
Give a very brief answer. 0.14. What is the ratio of the Expenses (in $) of Labor Taxes in 2002 to that in 2009?
Your answer should be very brief. 0.1. What is the ratio of the Expenses (in $) of Grants and Revenue in 2002 to that in 2009?
Your response must be concise. 0.15. What is the ratio of the Expenses (in $) of Services in 2002 to that in 2009?
Make the answer very short. 0.17. What is the ratio of the Expenses (in $) in Miscellaneous expenses in 2002 to that in 2010?
Your answer should be compact. 0.2. What is the ratio of the Expenses (in $) of Labor Taxes in 2002 to that in 2010?
Your response must be concise. 0.07. What is the ratio of the Expenses (in $) in Grants and Revenue in 2002 to that in 2010?
Offer a terse response. 0.23. What is the ratio of the Expenses (in $) in Services in 2002 to that in 2010?
Make the answer very short. 0.18. What is the ratio of the Expenses (in $) of Miscellaneous expenses in 2003 to that in 2004?
Your response must be concise. 0.79. What is the ratio of the Expenses (in $) of Labor Taxes in 2003 to that in 2004?
Make the answer very short. 0.94. What is the ratio of the Expenses (in $) in Grants and Revenue in 2003 to that in 2004?
Offer a terse response. 0.82. What is the ratio of the Expenses (in $) of Services in 2003 to that in 2004?
Offer a terse response. 0.47. What is the ratio of the Expenses (in $) of Miscellaneous expenses in 2003 to that in 2005?
Give a very brief answer. 0.53. What is the ratio of the Expenses (in $) in Labor Taxes in 2003 to that in 2005?
Ensure brevity in your answer.  0.78. What is the ratio of the Expenses (in $) of Grants and Revenue in 2003 to that in 2005?
Keep it short and to the point. 0.53. What is the ratio of the Expenses (in $) in Services in 2003 to that in 2005?
Your response must be concise. 0.34. What is the ratio of the Expenses (in $) in Miscellaneous expenses in 2003 to that in 2006?
Your response must be concise. 0.29. What is the ratio of the Expenses (in $) in Labor Taxes in 2003 to that in 2006?
Your answer should be very brief. 0.62. What is the ratio of the Expenses (in $) in Grants and Revenue in 2003 to that in 2006?
Offer a very short reply. 0.39. What is the ratio of the Expenses (in $) of Services in 2003 to that in 2006?
Your response must be concise. 0.25. What is the ratio of the Expenses (in $) of Miscellaneous expenses in 2003 to that in 2007?
Offer a very short reply. 0.29. What is the ratio of the Expenses (in $) in Labor Taxes in 2003 to that in 2007?
Provide a succinct answer. 0.51. What is the ratio of the Expenses (in $) in Grants and Revenue in 2003 to that in 2007?
Ensure brevity in your answer.  0.25. What is the ratio of the Expenses (in $) in Services in 2003 to that in 2007?
Offer a terse response. 0.21. What is the ratio of the Expenses (in $) of Miscellaneous expenses in 2003 to that in 2008?
Your response must be concise. 0.19. What is the ratio of the Expenses (in $) of Labor Taxes in 2003 to that in 2008?
Make the answer very short. 0.46. What is the ratio of the Expenses (in $) in Grants and Revenue in 2003 to that in 2008?
Offer a very short reply. 0.31. What is the ratio of the Expenses (in $) in Services in 2003 to that in 2008?
Your answer should be compact. 0.21. What is the ratio of the Expenses (in $) of Miscellaneous expenses in 2003 to that in 2009?
Your answer should be compact. 0.21. What is the ratio of the Expenses (in $) in Labor Taxes in 2003 to that in 2009?
Your answer should be compact. 0.45. What is the ratio of the Expenses (in $) in Grants and Revenue in 2003 to that in 2009?
Your answer should be very brief. 0.19. What is the ratio of the Expenses (in $) in Services in 2003 to that in 2009?
Provide a short and direct response. 0.16. What is the ratio of the Expenses (in $) in Miscellaneous expenses in 2003 to that in 2010?
Your response must be concise. 0.31. What is the ratio of the Expenses (in $) in Labor Taxes in 2003 to that in 2010?
Offer a very short reply. 0.34. What is the ratio of the Expenses (in $) in Grants and Revenue in 2003 to that in 2010?
Keep it short and to the point. 0.29. What is the ratio of the Expenses (in $) of Services in 2003 to that in 2010?
Ensure brevity in your answer.  0.16. What is the ratio of the Expenses (in $) in Miscellaneous expenses in 2004 to that in 2005?
Offer a terse response. 0.68. What is the ratio of the Expenses (in $) in Labor Taxes in 2004 to that in 2005?
Ensure brevity in your answer.  0.82. What is the ratio of the Expenses (in $) in Grants and Revenue in 2004 to that in 2005?
Provide a short and direct response. 0.64. What is the ratio of the Expenses (in $) of Services in 2004 to that in 2005?
Your answer should be compact. 0.72. What is the ratio of the Expenses (in $) of Miscellaneous expenses in 2004 to that in 2006?
Offer a very short reply. 0.36. What is the ratio of the Expenses (in $) in Labor Taxes in 2004 to that in 2006?
Keep it short and to the point. 0.66. What is the ratio of the Expenses (in $) of Grants and Revenue in 2004 to that in 2006?
Your answer should be very brief. 0.48. What is the ratio of the Expenses (in $) in Services in 2004 to that in 2006?
Your answer should be compact. 0.53. What is the ratio of the Expenses (in $) of Miscellaneous expenses in 2004 to that in 2007?
Your response must be concise. 0.37. What is the ratio of the Expenses (in $) of Labor Taxes in 2004 to that in 2007?
Your answer should be very brief. 0.54. What is the ratio of the Expenses (in $) of Grants and Revenue in 2004 to that in 2007?
Ensure brevity in your answer.  0.3. What is the ratio of the Expenses (in $) of Services in 2004 to that in 2007?
Your answer should be very brief. 0.46. What is the ratio of the Expenses (in $) of Miscellaneous expenses in 2004 to that in 2008?
Keep it short and to the point. 0.24. What is the ratio of the Expenses (in $) in Labor Taxes in 2004 to that in 2008?
Provide a succinct answer. 0.48. What is the ratio of the Expenses (in $) in Grants and Revenue in 2004 to that in 2008?
Your answer should be very brief. 0.38. What is the ratio of the Expenses (in $) in Services in 2004 to that in 2008?
Your response must be concise. 0.45. What is the ratio of the Expenses (in $) of Miscellaneous expenses in 2004 to that in 2009?
Give a very brief answer. 0.27. What is the ratio of the Expenses (in $) of Labor Taxes in 2004 to that in 2009?
Provide a succinct answer. 0.48. What is the ratio of the Expenses (in $) in Grants and Revenue in 2004 to that in 2009?
Make the answer very short. 0.23. What is the ratio of the Expenses (in $) in Services in 2004 to that in 2009?
Provide a short and direct response. 0.34. What is the ratio of the Expenses (in $) in Miscellaneous expenses in 2004 to that in 2010?
Give a very brief answer. 0.39. What is the ratio of the Expenses (in $) in Labor Taxes in 2004 to that in 2010?
Ensure brevity in your answer.  0.36. What is the ratio of the Expenses (in $) of Grants and Revenue in 2004 to that in 2010?
Give a very brief answer. 0.35. What is the ratio of the Expenses (in $) of Services in 2004 to that in 2010?
Keep it short and to the point. 0.34. What is the ratio of the Expenses (in $) in Miscellaneous expenses in 2005 to that in 2006?
Offer a terse response. 0.54. What is the ratio of the Expenses (in $) of Labor Taxes in 2005 to that in 2006?
Give a very brief answer. 0.8. What is the ratio of the Expenses (in $) in Grants and Revenue in 2005 to that in 2006?
Offer a terse response. 0.74. What is the ratio of the Expenses (in $) of Services in 2005 to that in 2006?
Your answer should be compact. 0.73. What is the ratio of the Expenses (in $) in Miscellaneous expenses in 2005 to that in 2007?
Keep it short and to the point. 0.55. What is the ratio of the Expenses (in $) of Labor Taxes in 2005 to that in 2007?
Provide a short and direct response. 0.65. What is the ratio of the Expenses (in $) in Grants and Revenue in 2005 to that in 2007?
Provide a succinct answer. 0.47. What is the ratio of the Expenses (in $) in Services in 2005 to that in 2007?
Provide a succinct answer. 0.63. What is the ratio of the Expenses (in $) in Miscellaneous expenses in 2005 to that in 2008?
Make the answer very short. 0.35. What is the ratio of the Expenses (in $) in Labor Taxes in 2005 to that in 2008?
Your answer should be compact. 0.59. What is the ratio of the Expenses (in $) of Grants and Revenue in 2005 to that in 2008?
Keep it short and to the point. 0.59. What is the ratio of the Expenses (in $) in Services in 2005 to that in 2008?
Give a very brief answer. 0.62. What is the ratio of the Expenses (in $) in Miscellaneous expenses in 2005 to that in 2009?
Provide a short and direct response. 0.4. What is the ratio of the Expenses (in $) in Labor Taxes in 2005 to that in 2009?
Provide a short and direct response. 0.58. What is the ratio of the Expenses (in $) of Grants and Revenue in 2005 to that in 2009?
Offer a very short reply. 0.35. What is the ratio of the Expenses (in $) of Services in 2005 to that in 2009?
Your answer should be very brief. 0.47. What is the ratio of the Expenses (in $) of Miscellaneous expenses in 2005 to that in 2010?
Provide a succinct answer. 0.58. What is the ratio of the Expenses (in $) in Labor Taxes in 2005 to that in 2010?
Offer a very short reply. 0.44. What is the ratio of the Expenses (in $) of Grants and Revenue in 2005 to that in 2010?
Ensure brevity in your answer.  0.54. What is the ratio of the Expenses (in $) of Services in 2005 to that in 2010?
Provide a short and direct response. 0.48. What is the ratio of the Expenses (in $) of Miscellaneous expenses in 2006 to that in 2007?
Give a very brief answer. 1.02. What is the ratio of the Expenses (in $) in Labor Taxes in 2006 to that in 2007?
Offer a very short reply. 0.81. What is the ratio of the Expenses (in $) in Grants and Revenue in 2006 to that in 2007?
Offer a very short reply. 0.63. What is the ratio of the Expenses (in $) in Services in 2006 to that in 2007?
Give a very brief answer. 0.87. What is the ratio of the Expenses (in $) of Miscellaneous expenses in 2006 to that in 2008?
Offer a very short reply. 0.66. What is the ratio of the Expenses (in $) of Labor Taxes in 2006 to that in 2008?
Provide a short and direct response. 0.73. What is the ratio of the Expenses (in $) of Grants and Revenue in 2006 to that in 2008?
Offer a very short reply. 0.79. What is the ratio of the Expenses (in $) of Services in 2006 to that in 2008?
Ensure brevity in your answer.  0.85. What is the ratio of the Expenses (in $) in Miscellaneous expenses in 2006 to that in 2009?
Ensure brevity in your answer.  0.74. What is the ratio of the Expenses (in $) in Labor Taxes in 2006 to that in 2009?
Your answer should be very brief. 0.72. What is the ratio of the Expenses (in $) in Grants and Revenue in 2006 to that in 2009?
Provide a succinct answer. 0.48. What is the ratio of the Expenses (in $) in Services in 2006 to that in 2009?
Provide a succinct answer. 0.64. What is the ratio of the Expenses (in $) of Miscellaneous expenses in 2006 to that in 2010?
Offer a very short reply. 1.07. What is the ratio of the Expenses (in $) of Labor Taxes in 2006 to that in 2010?
Provide a short and direct response. 0.55. What is the ratio of the Expenses (in $) in Grants and Revenue in 2006 to that in 2010?
Keep it short and to the point. 0.73. What is the ratio of the Expenses (in $) in Services in 2006 to that in 2010?
Offer a terse response. 0.65. What is the ratio of the Expenses (in $) in Miscellaneous expenses in 2007 to that in 2008?
Provide a short and direct response. 0.65. What is the ratio of the Expenses (in $) in Labor Taxes in 2007 to that in 2008?
Make the answer very short. 0.9. What is the ratio of the Expenses (in $) in Grants and Revenue in 2007 to that in 2008?
Ensure brevity in your answer.  1.26. What is the ratio of the Expenses (in $) in Services in 2007 to that in 2008?
Offer a very short reply. 0.99. What is the ratio of the Expenses (in $) of Miscellaneous expenses in 2007 to that in 2009?
Keep it short and to the point. 0.73. What is the ratio of the Expenses (in $) in Labor Taxes in 2007 to that in 2009?
Keep it short and to the point. 0.89. What is the ratio of the Expenses (in $) in Grants and Revenue in 2007 to that in 2009?
Keep it short and to the point. 0.76. What is the ratio of the Expenses (in $) of Services in 2007 to that in 2009?
Your response must be concise. 0.74. What is the ratio of the Expenses (in $) of Miscellaneous expenses in 2007 to that in 2010?
Give a very brief answer. 1.05. What is the ratio of the Expenses (in $) of Labor Taxes in 2007 to that in 2010?
Your answer should be very brief. 0.68. What is the ratio of the Expenses (in $) of Grants and Revenue in 2007 to that in 2010?
Your answer should be compact. 1.16. What is the ratio of the Expenses (in $) in Services in 2007 to that in 2010?
Ensure brevity in your answer.  0.75. What is the ratio of the Expenses (in $) in Miscellaneous expenses in 2008 to that in 2009?
Offer a terse response. 1.13. What is the ratio of the Expenses (in $) in Labor Taxes in 2008 to that in 2009?
Provide a short and direct response. 0.98. What is the ratio of the Expenses (in $) in Grants and Revenue in 2008 to that in 2009?
Keep it short and to the point. 0.6. What is the ratio of the Expenses (in $) in Services in 2008 to that in 2009?
Keep it short and to the point. 0.75. What is the ratio of the Expenses (in $) in Miscellaneous expenses in 2008 to that in 2010?
Provide a succinct answer. 1.63. What is the ratio of the Expenses (in $) of Labor Taxes in 2008 to that in 2010?
Give a very brief answer. 0.76. What is the ratio of the Expenses (in $) in Grants and Revenue in 2008 to that in 2010?
Keep it short and to the point. 0.92. What is the ratio of the Expenses (in $) in Services in 2008 to that in 2010?
Offer a terse response. 0.76. What is the ratio of the Expenses (in $) of Miscellaneous expenses in 2009 to that in 2010?
Your response must be concise. 1.44. What is the ratio of the Expenses (in $) in Labor Taxes in 2009 to that in 2010?
Make the answer very short. 0.77. What is the ratio of the Expenses (in $) in Grants and Revenue in 2009 to that in 2010?
Your answer should be compact. 1.53. What is the ratio of the Expenses (in $) in Services in 2009 to that in 2010?
Provide a succinct answer. 1.02. What is the difference between the highest and the second highest Expenses (in $) of Miscellaneous expenses?
Offer a terse response. 2.88e+07. What is the difference between the highest and the second highest Expenses (in $) in Labor Taxes?
Provide a short and direct response. 2.59e+07. What is the difference between the highest and the second highest Expenses (in $) of Grants and Revenue?
Offer a terse response. 2.66e+08. What is the difference between the highest and the second highest Expenses (in $) of Services?
Offer a very short reply. 1.36e+07. What is the difference between the highest and the lowest Expenses (in $) of Miscellaneous expenses?
Offer a terse response. 2.14e+08. What is the difference between the highest and the lowest Expenses (in $) of Labor Taxes?
Make the answer very short. 1.03e+08. What is the difference between the highest and the lowest Expenses (in $) in Grants and Revenue?
Your answer should be compact. 9.49e+08. What is the difference between the highest and the lowest Expenses (in $) of Services?
Provide a succinct answer. 5.50e+08. 